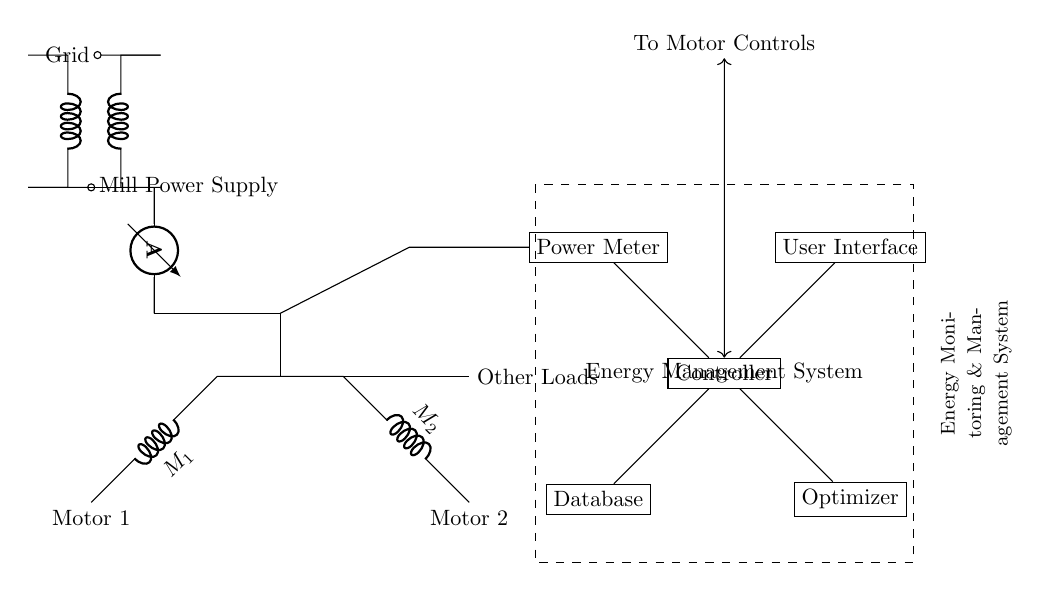What type of transformer is used in this circuit? The circuit includes a transformer labeled "T1", which indicates it is a step-down or step-up transformer based on its connections to the grid and mill power supply.
Answer: transformer How many motors are present in the circuit? The circuit diagram shows two distinct components labeled "Motor 1" and "Motor 2", indicating that there are two motors connected in parallel.
Answer: two What is the purpose of the power meter in this circuit? The power meter is connected to the power supply line and feeds information to the energy management system, thus the purpose is to monitor and report the power consumption of the motors and loads.
Answer: monitor power consumption What component is responsible for optimizing energy use? The optimizer component is specifically labeled in the circuit, and its connection to the controller indicates that it’s designed to manage energy efficiency across the various loads in the system.
Answer: optimizer Which component interfaces with the user? The user interface is labeled explicitly in the circuit and is connected to the controller, making it the component through which users interact with the energy management system.
Answer: user interface What type of loads are connected in the circuit along with the motors? The connections show that there are unspecified "Other Loads" connected parallel to the motors, indicating this circuit can handle additional electrical devices besides the two motors.
Answer: Other Loads 